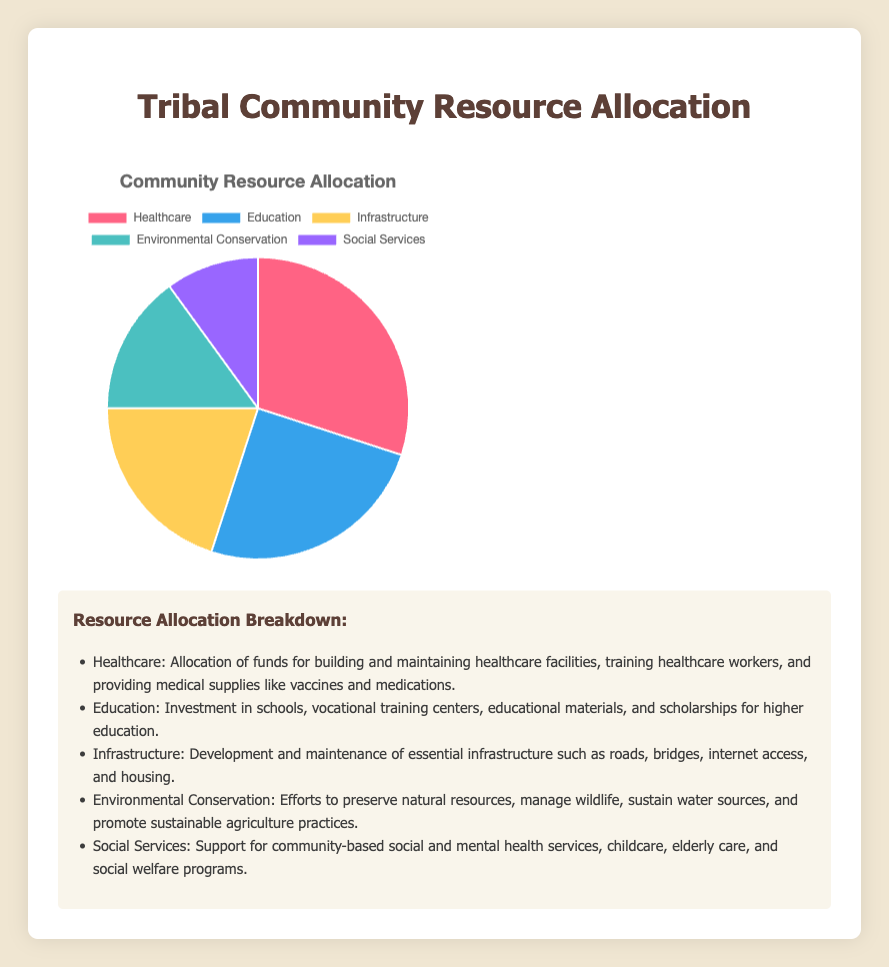what percentage of the community's resources is allocated to healthcare? The pie chart shows that 30% of the community's resources are allocated to healthcare.
Answer: 30% which category receives the second highest allocation of resources? By examining the pie chart, Education receives the second highest allocation with 25%.
Answer: Education what is the combined percentage of resources allocated to infrastructure and social services? Adding the percentages for infrastructure (20%) and social services (10%) gives a total of 30%.
Answer: 30% how much greater is the allocation for healthcare compared to environmental conservation? The difference between the percentage for healthcare (30%) and environmental conservation (15%) is 15%.
Answer: 15% is the allocation for education more or less than that for infrastructure? The allocation for education (25%) is more than that for infrastructure (20%).
Answer: More which two categories together make up half of the total allocation? Healthcare (30%) and infrastructure (20%) together make up 50% of the total allocation.
Answer: Healthcare and Infrastructure what percentage is allocated to categories other than healthcare? Subtracting healthcare's allocation (30%) from 100% leaves 70% for other categories.
Answer: 70% what proportion of the total allocation goes to social services? The allocation for social services is 10% of the total.
Answer: 10% which category has the least allocation of resources? Social services have the least allocation at 10%.
Answer: Social Services 